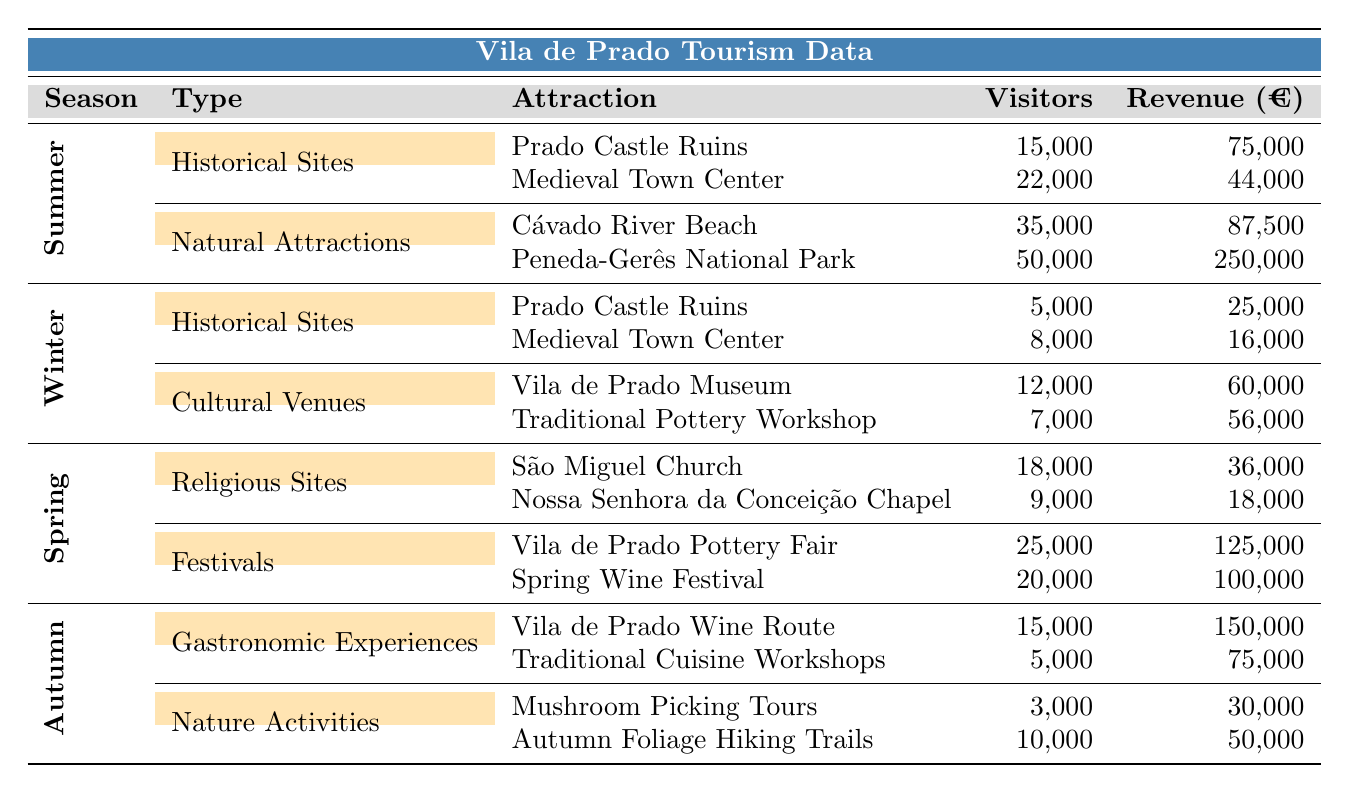What is the total revenue generated by Historical Sites in Summer? In the Summer season, there are two Historical Sites: Prado Castle Ruins generating €75,000 and Medieval Town Center generating €44,000. Adding these together gives €75,000 + €44,000 = €119,000.
Answer: €119,000 Which season has the highest total number of visitors? To find the season with the most visitors, add the visitors for each season: Summer (15,000 + 22,000 + 35,000 + 50,000 = 122,000), Winter (5,000 + 8,000 + 12,000 + 7,000 = 32,000), Spring (18,000 + 9,000 + 25,000 + 20,000 = 72,000), Autumn (15,000 + 5,000 + 3,000 + 10,000 = 33,000). The highest is Summer with 122,000 visitors.
Answer: Summer Did more people visit natural attractions than historical sites in Summer? In Summer, Historical Sites had 15,000 + 22,000 = 37,000 visitors, while Natural Attractions had 35,000 + 50,000 = 85,000 visitors. Since 85,000 is greater than 37,000, more people visited natural attractions.
Answer: Yes What is the average revenue generated by Cultural Venues in Winter? There are two Cultural Venues: Vila de Prado Museum generating €60,000 and Traditional Pottery Workshop generating €56,000. The total revenue is €60,000 + €56,000 = €116,000. The average is this total divided by the number of venues, which is £116,000 / 2 = €58,000.
Answer: €58,000 In Spring, which festival attracted more visitors: Vila de Prado Pottery Fair or Spring Wine Festival? The Vila de Prado Pottery Fair had 25,000 visitors, while the Spring Wine Festival had 20,000 visitors. Since 25,000 is greater than 20,000, the Pottery Fair attracted more visitors.
Answer: Vila de Prado Pottery Fair What is the total number of visitors to attractions in Autumn? In Autumn, the visitors sum up as follows: Vila de Prado Wine Route (15,000) + Traditional Cuisine Workshops (5,000) + Mushroom Picking Tours (3,000) + Autumn Foliage Hiking Trails (10,000) = 15,000 + 5,000 + 3,000 + 10,000 = 33,000 visitors in total.
Answer: 33,000 Which type of attraction had the highest revenue in Summer? In Summer, Natural Attractions generated €87,500 from Cávado River Beach and €250,000 from Peneda-Gerês National Park, totaling €337,500. Historical Sites generated €119,000. Since €337,500 is greater than €119,000, Natural Attractions had the highest revenue.
Answer: Natural Attractions Is the revenue from all festivals in Spring greater than the revenue from all religious sites? In Spring, the total revenue from festivals (Vila de Prado Pottery Fair €125,000 + Spring Wine Festival €100,000 = €225,000) compared to religious sites (São Miguel Church €36,000 + Nossa Senhora da Conceição Chapel €18,000 = €54,000). Since €225,000 is greater than €54,000, the statement is true.
Answer: Yes What is the seasonal trend of visitor numbers from Winter to Summer? The seasonal visitor counts are Winter (32,000), Spring (72,000), Summer (122,000). Observing these values shows an increasing trend from Winter to Spring to Summer, indicating a growth in visitor numbers as the seasons progress.
Answer: Increasing Which attraction had the lowest revenue in Autumn? In Autumn, the Traditional Cuisine Workshops had €75,000, Mushroom Picking Tours had €30,000, and Autumn Foliage Hiking Trails had €50,000. The lowest revenue is observed from Mushroom Picking Tours at €30,000.
Answer: Mushroom Picking Tours 